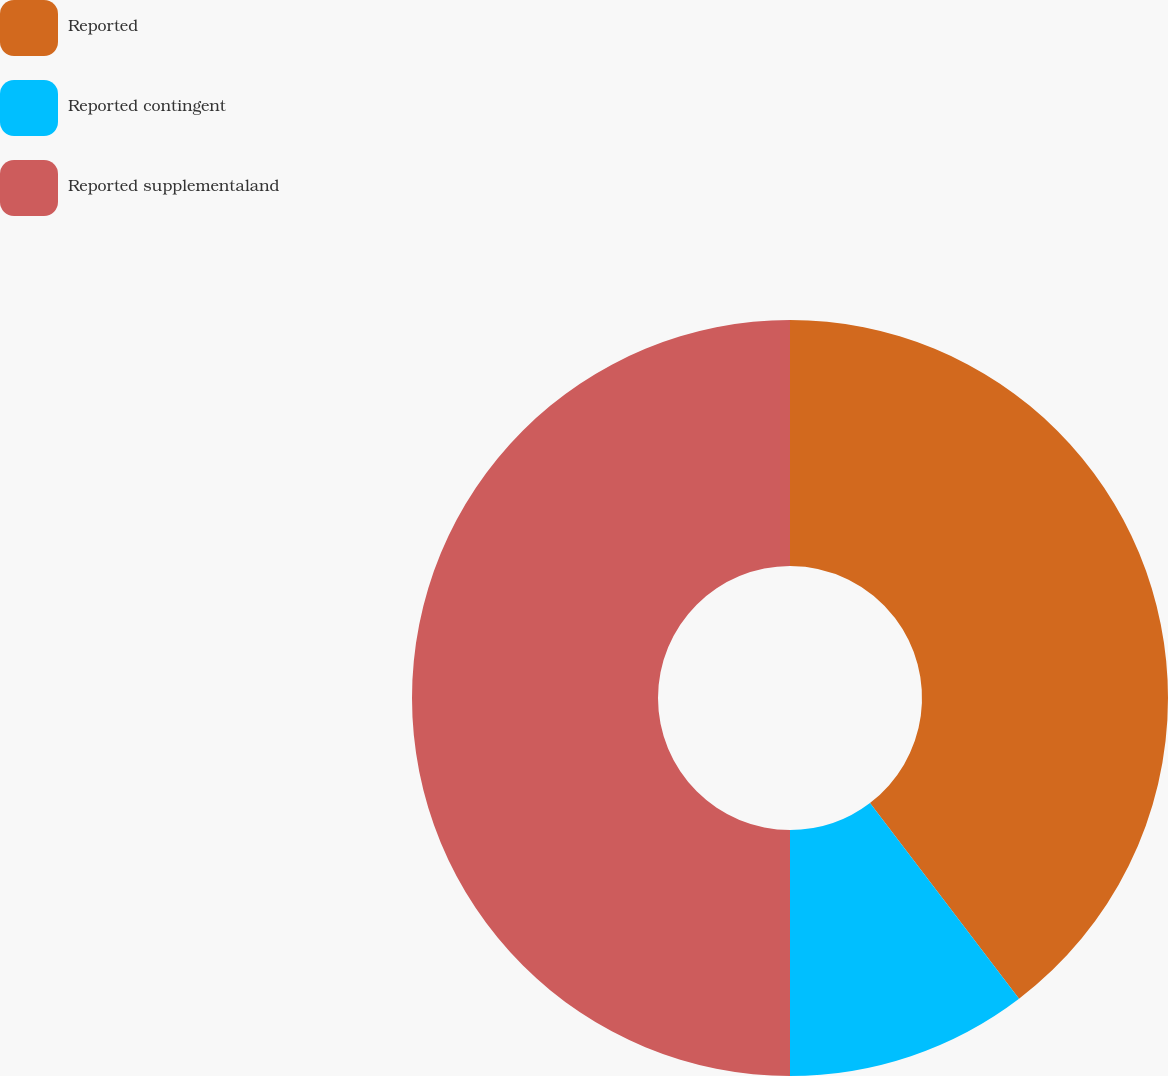Convert chart. <chart><loc_0><loc_0><loc_500><loc_500><pie_chart><fcel>Reported<fcel>Reported contingent<fcel>Reported supplementaland<nl><fcel>39.64%<fcel>10.36%<fcel>50.0%<nl></chart> 